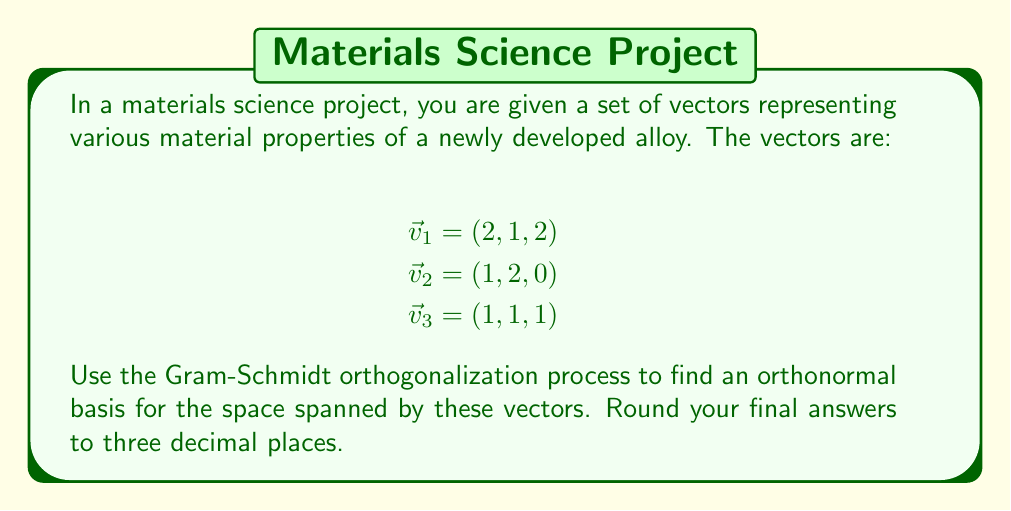Could you help me with this problem? Let's apply the Gram-Schmidt process to orthogonalize the given vectors:

Step 1: Let $\vec{u}_1 = \vec{v}_1$
$$\vec{u}_1 = (2, 1, 2)$$

Step 2: Calculate $\vec{u}_2$
$$\vec{u}_2 = \vec{v}_2 - \text{proj}_{\vec{u}_1}(\vec{v}_2)$$
$$= \vec{v}_2 - \frac{\vec{v}_2 \cdot \vec{u}_1}{\|\vec{u}_1\|^2}\vec{u}_1$$
$$= (1, 2, 0) - \frac{(1,2,0) \cdot (2,1,2)}{(2,1,2) \cdot (2,1,2)}(2,1,2)$$
$$= (1, 2, 0) - \frac{4}{9}(2,1,2)$$
$$= (1, 2, 0) - (\frac{8}{9}, \frac{4}{9}, \frac{8}{9})$$
$$= (\frac{1}{9}, \frac{14}{9}, -\frac{8}{9})$$

Step 3: Calculate $\vec{u}_3$
$$\vec{u}_3 = \vec{v}_3 - \text{proj}_{\vec{u}_1}(\vec{v}_3) - \text{proj}_{\vec{u}_2}(\vec{v}_3)$$
$$= \vec{v}_3 - \frac{\vec{v}_3 \cdot \vec{u}_1}{\|\vec{u}_1\|^2}\vec{u}_1 - \frac{\vec{v}_3 \cdot \vec{u}_2}{\|\vec{u}_2\|^2}\vec{u}_2$$
$$= (1,1,1) - \frac{5}{9}(2,1,2) - \frac{7}{243}(\frac{1}{9}, \frac{14}{9}, -\frac{8}{9})$$
$$= (1,1,1) - (\frac{10}{9}, \frac{5}{9}, \frac{10}{9}) - (\frac{1}{243}, \frac{14}{243}, -\frac{8}{243})$$
$$= (\frac{80}{243}, \frac{224}{243}, \frac{241}{243})$$

Now, we need to normalize these vectors to create an orthonormal basis:

$$\vec{e}_1 = \frac{\vec{u}_1}{\|\vec{u}_1\|} = \frac{(2,1,2)}{\sqrt{9}} = (\frac{2}{3}, \frac{1}{3}, \frac{2}{3})$$

$$\vec{e}_2 = \frac{\vec{u}_2}{\|\vec{u}_2\|} = \frac{(\frac{1}{9}, \frac{14}{9}, -\frac{8}{9})}{\sqrt{(\frac{1}{9})^2 + (\frac{14}{9})^2 + (-\frac{8}{9})^2}} = (0.060, 0.840, -0.480)$$

$$\vec{e}_3 = \frac{\vec{u}_3}{\|\vec{u}_3\|} = \frac{(\frac{80}{243}, \frac{224}{243}, \frac{241}{243})}{\sqrt{(\frac{80}{243})^2 + (\frac{224}{243})^2 + (\frac{241}{243})^2}} = (0.236, 0.661, 0.712)$$

Rounding to three decimal places gives us our final orthonormal basis.
Answer: $\vec{e}_1 = (0.667, 0.333, 0.667)$, $\vec{e}_2 = (0.060, 0.840, -0.480)$, $\vec{e}_3 = (0.236, 0.661, 0.712)$ 